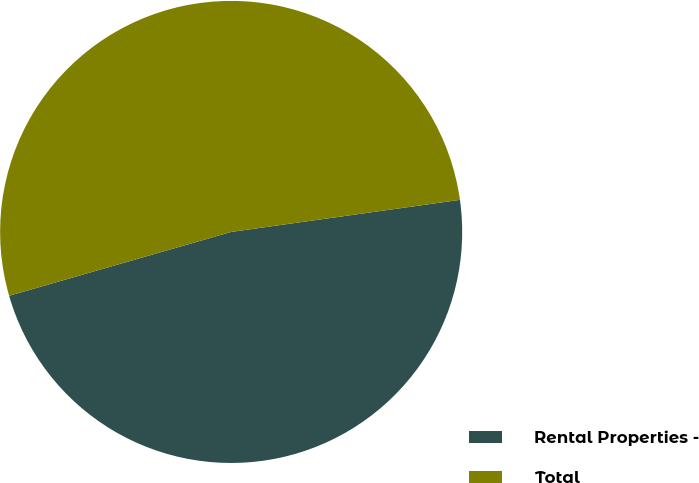<chart> <loc_0><loc_0><loc_500><loc_500><pie_chart><fcel>Rental Properties -<fcel>Total<nl><fcel>47.76%<fcel>52.24%<nl></chart> 